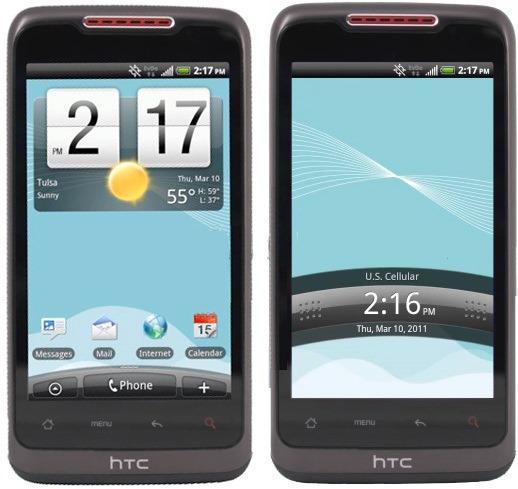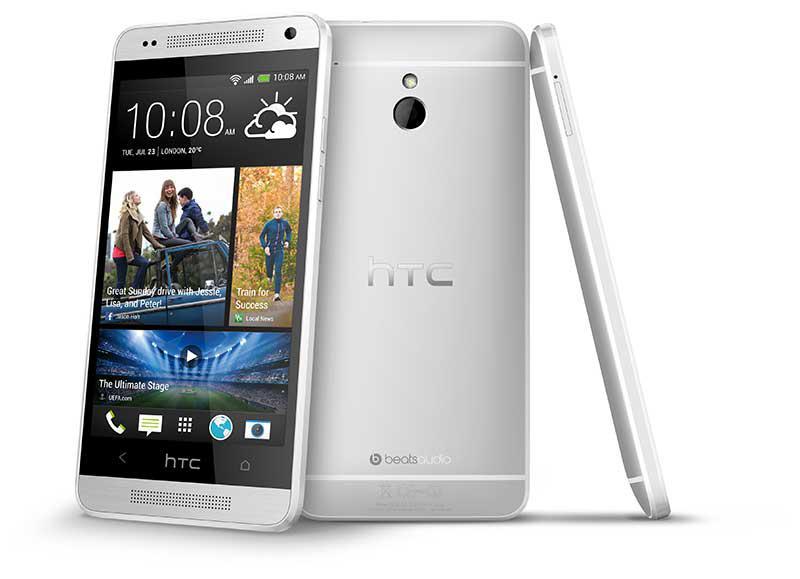The first image is the image on the left, the second image is the image on the right. Considering the images on both sides, is "A phone's side profile is in the right image." valid? Answer yes or no. Yes. The first image is the image on the left, the second image is the image on the right. Considering the images on both sides, is "There are more phones in the image on the right, and only a single phone in the image on the left." valid? Answer yes or no. No. 